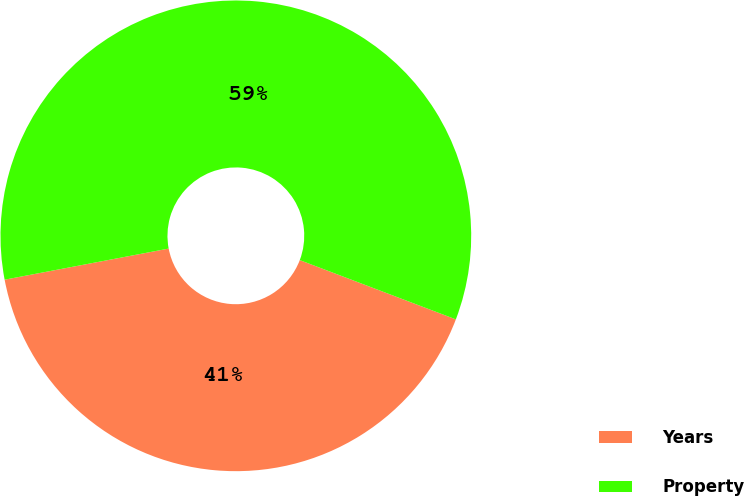<chart> <loc_0><loc_0><loc_500><loc_500><pie_chart><fcel>Years<fcel>Property<nl><fcel>41.24%<fcel>58.76%<nl></chart> 